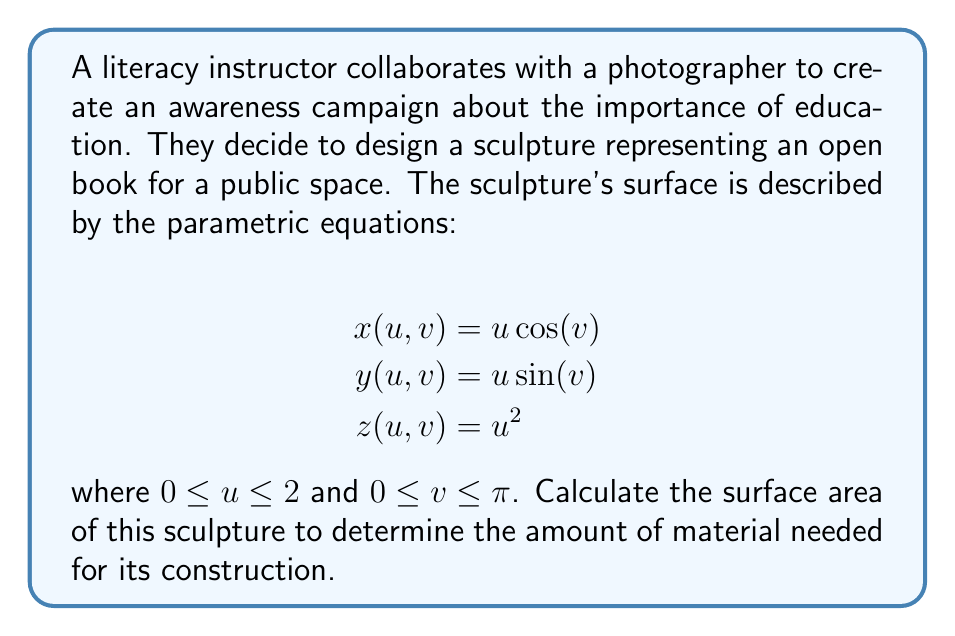Can you answer this question? To calculate the surface area of a parametric surface, we use the surface integral formula:

$$A = \int\int_S \sqrt{EG - F^2} \, du \, dv$$

where $E$, $F$, and $G$ are the coefficients of the first fundamental form.

Step 1: Calculate partial derivatives
$$\frac{\partial x}{\partial u} = \cos(v), \frac{\partial x}{\partial v} = -u\sin(v)$$
$$\frac{\partial y}{\partial u} = \sin(v), \frac{\partial y}{\partial v} = u\cos(v)$$
$$\frac{\partial z}{\partial u} = 2u, \frac{\partial z}{\partial v} = 0$$

Step 2: Calculate $E$, $F$, and $G$
$$E = (\frac{\partial x}{\partial u})^2 + (\frac{\partial y}{\partial u})^2 + (\frac{\partial z}{\partial u})^2 = \cos^2(v) + \sin^2(v) + 4u^2 = 1 + 4u^2$$
$$F = \frac{\partial x}{\partial u}\frac{\partial x}{\partial v} + \frac{\partial y}{\partial u}\frac{\partial y}{\partial v} + \frac{\partial z}{\partial u}\frac{\partial z}{\partial v} = -u\sin(v)\cos(v) + u\sin(v)\cos(v) + 0 = 0$$
$$G = (\frac{\partial x}{\partial v})^2 + (\frac{\partial y}{\partial v})^2 + (\frac{\partial z}{\partial v})^2 = u^2\sin^2(v) + u^2\cos^2(v) + 0 = u^2$$

Step 3: Calculate $EG - F^2$
$$EG - F^2 = (1 + 4u^2)(u^2) - 0^2 = u^2 + 4u^4$$

Step 4: Set up the surface integral
$$A = \int_0^\pi \int_0^2 \sqrt{u^2 + 4u^4} \, du \, dv$$

Step 5: Evaluate the integral
First, integrate with respect to $u$:
$$\int_0^2 \sqrt{u^2 + 4u^4} \, du = \frac{1}{12}(1 + 2u^2)\sqrt{1 + 4u^2}(3 + 2u^2)\Big|_0^2$$
$$= \frac{1}{12}(1 + 8)\sqrt{1 + 16}(3 + 8) - 0 = \frac{9}{12}\sqrt{17} \cdot 11 = \frac{33}{4}\sqrt{17}$$

Now, integrate with respect to $v$:
$$A = \int_0^\pi \frac{33}{4}\sqrt{17} \, dv = \frac{33}{4}\sqrt{17} \cdot \pi$$

Therefore, the surface area of the sculpture is $\frac{33\pi}{4}\sqrt{17}$ square units.
Answer: $\frac{33\pi}{4}\sqrt{17}$ square units 